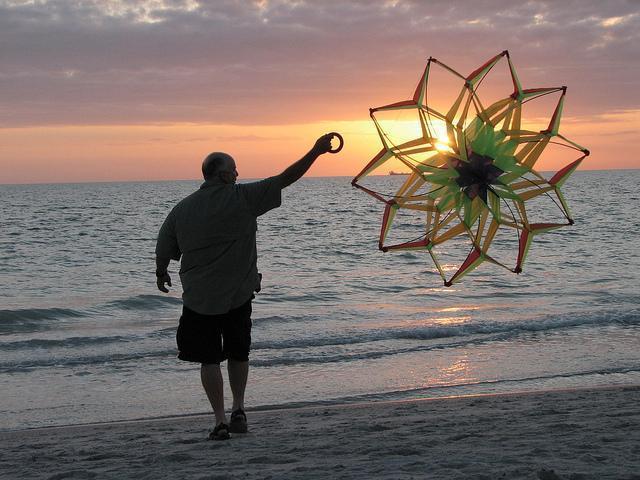How many cats are there?
Give a very brief answer. 0. 